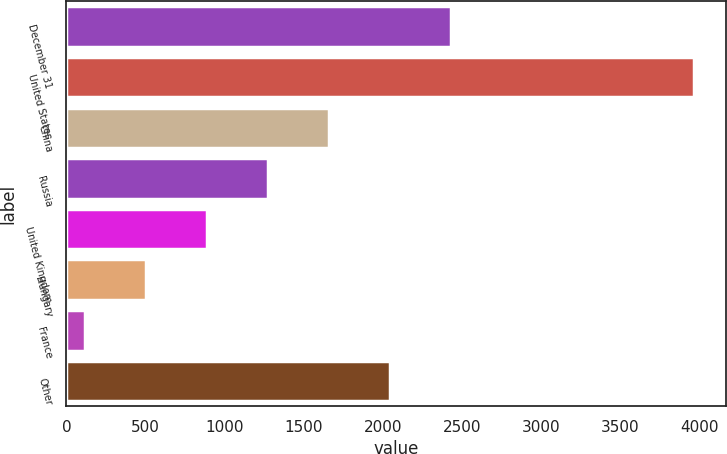<chart> <loc_0><loc_0><loc_500><loc_500><bar_chart><fcel>December 31<fcel>United States<fcel>China<fcel>Russia<fcel>United Kingdom<fcel>Hungary<fcel>France<fcel>Other<nl><fcel>2426.8<fcel>3966<fcel>1657.2<fcel>1272.4<fcel>887.6<fcel>502.8<fcel>118<fcel>2042<nl></chart> 